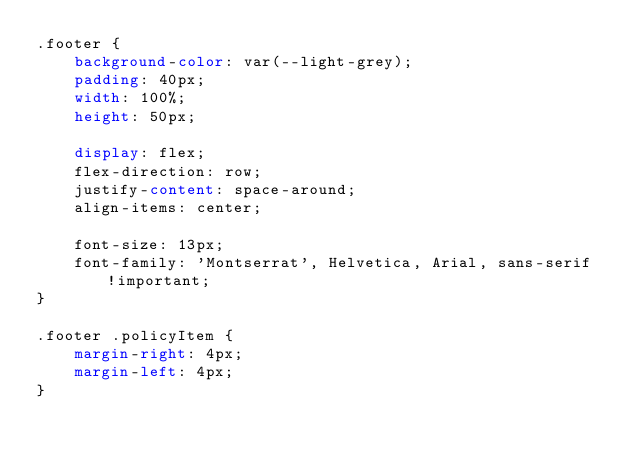Convert code to text. <code><loc_0><loc_0><loc_500><loc_500><_CSS_>.footer {
    background-color: var(--light-grey);
    padding: 40px;
    width: 100%;
    height: 50px;

    display: flex;
    flex-direction: row;
    justify-content: space-around;
    align-items: center;

    font-size: 13px;
    font-family: 'Montserrat', Helvetica, Arial, sans-serif !important;
}

.footer .policyItem {
    margin-right: 4px;
    margin-left: 4px;
}
</code> 